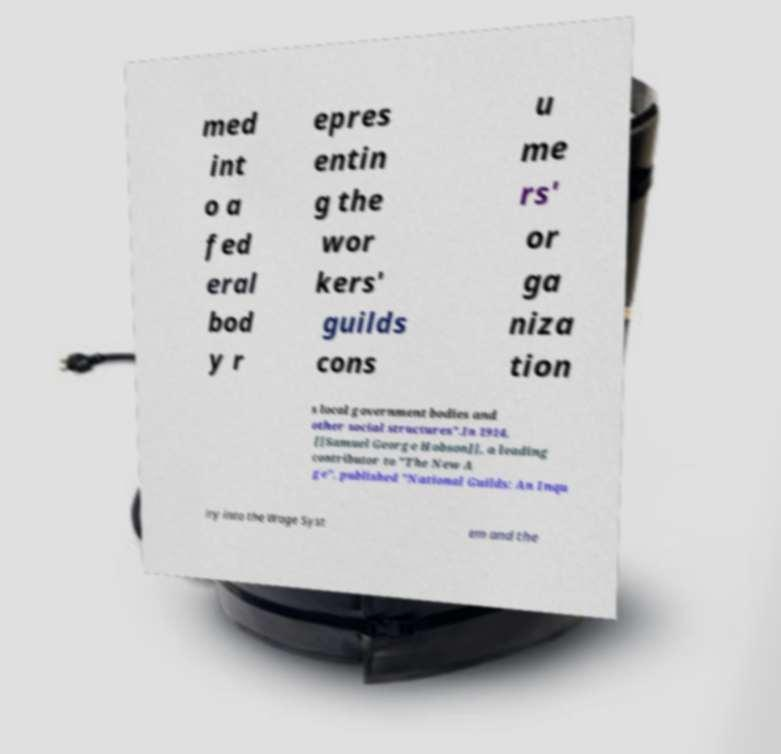Could you extract and type out the text from this image? med int o a fed eral bod y r epres entin g the wor kers' guilds cons u me rs' or ga niza tion s local government bodies and other social structures".In 1914, [[Samuel George Hobson]], a leading contributor to "The New A ge", published "National Guilds: An Inqu iry into the Wage Syst em and the 